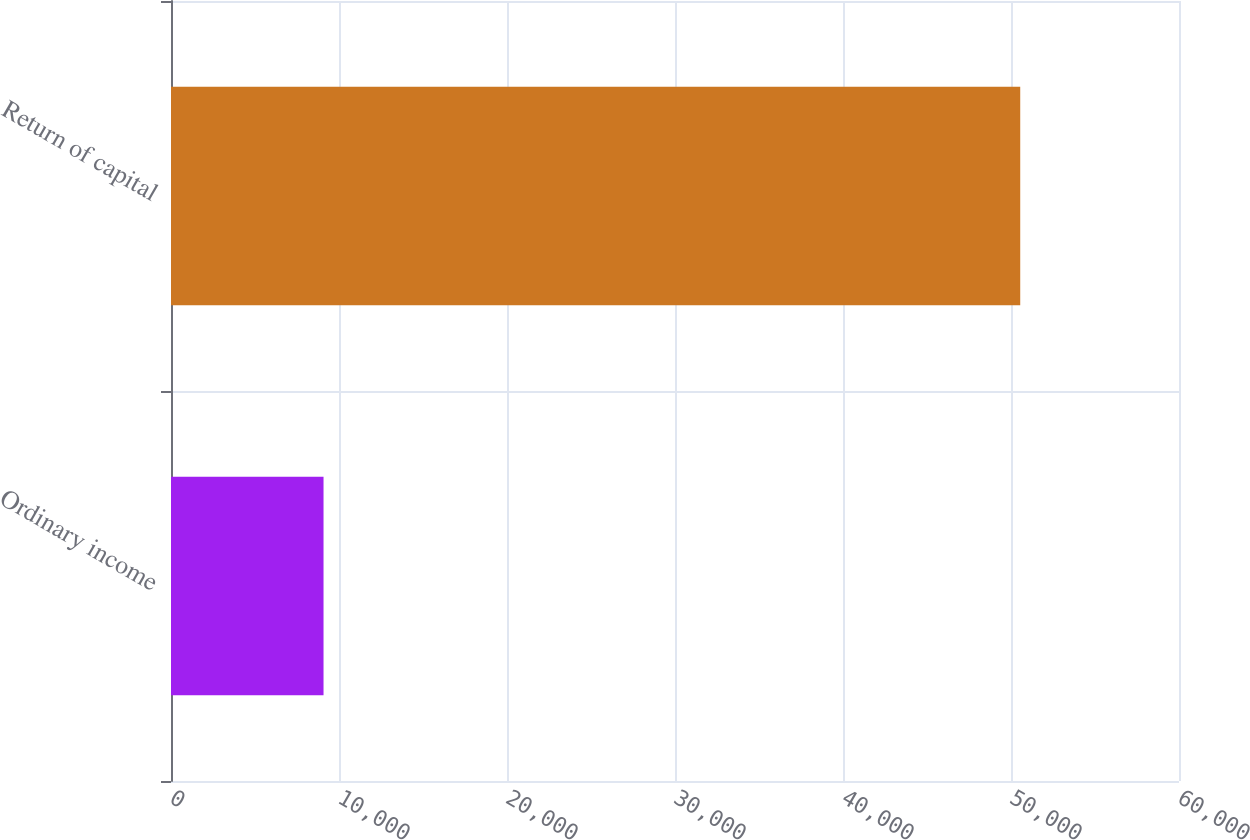<chart> <loc_0><loc_0><loc_500><loc_500><bar_chart><fcel>Ordinary income<fcel>Return of capital<nl><fcel>9079<fcel>50549<nl></chart> 